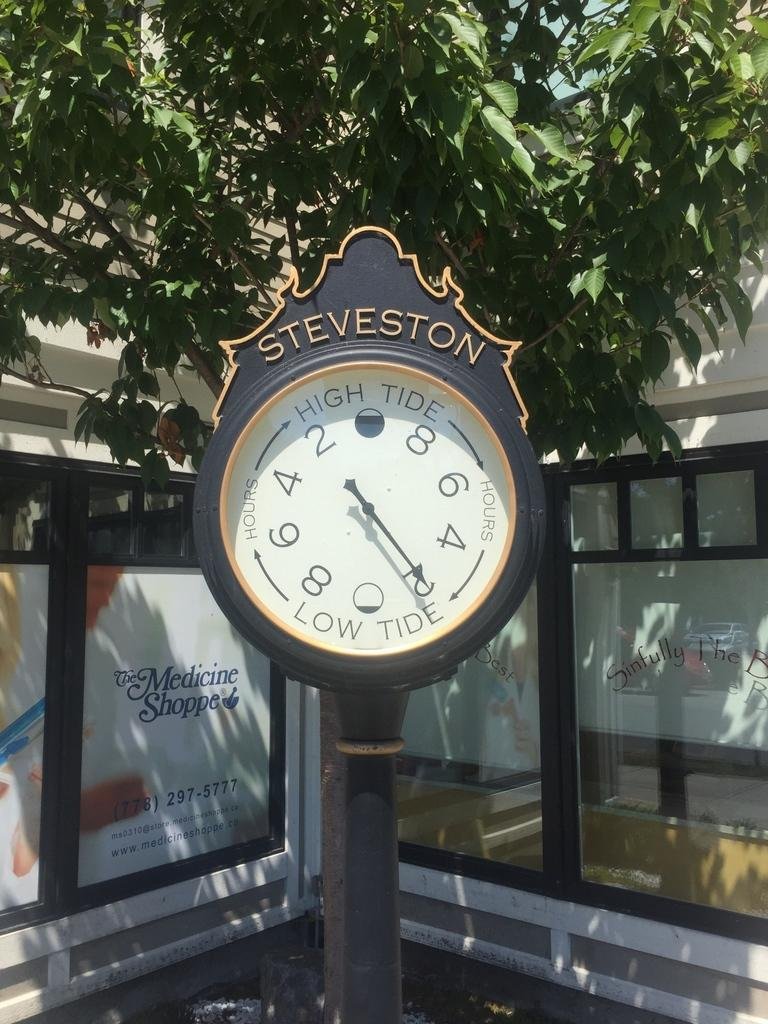<image>
Present a compact description of the photo's key features. Steveston High Tide and Low Tide clock outside 